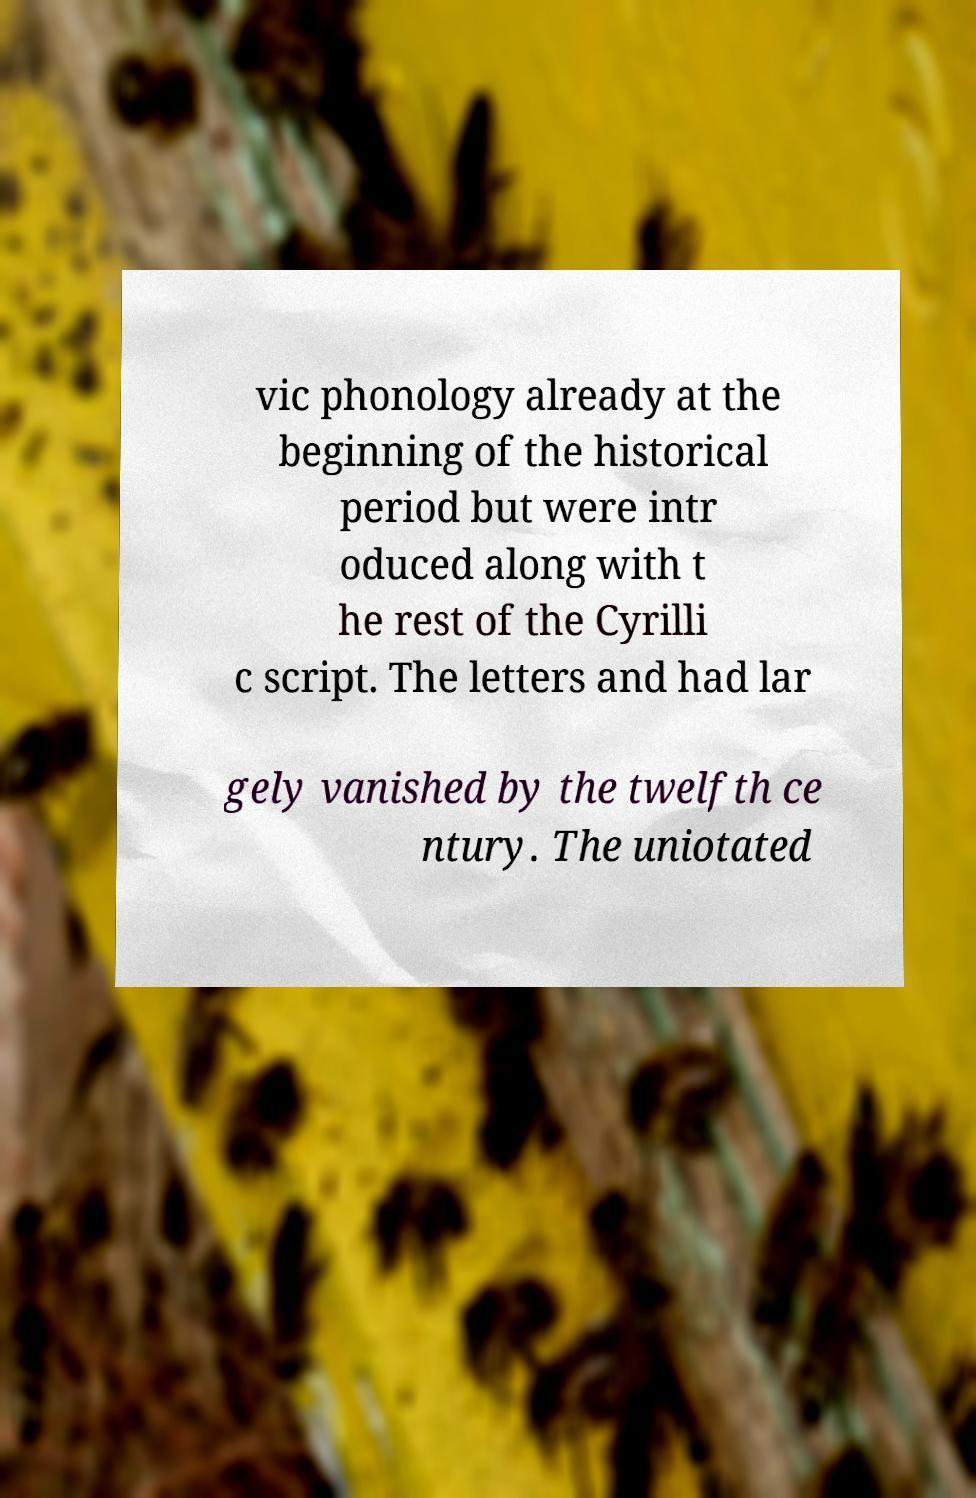What messages or text are displayed in this image? I need them in a readable, typed format. vic phonology already at the beginning of the historical period but were intr oduced along with t he rest of the Cyrilli c script. The letters and had lar gely vanished by the twelfth ce ntury. The uniotated 